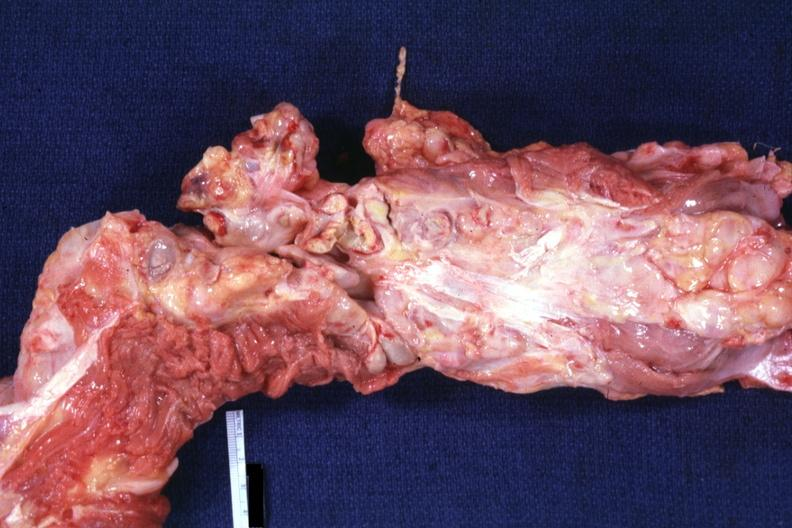does this image show aorta not opened surrounded by large nodes?
Answer the question using a single word or phrase. Yes 